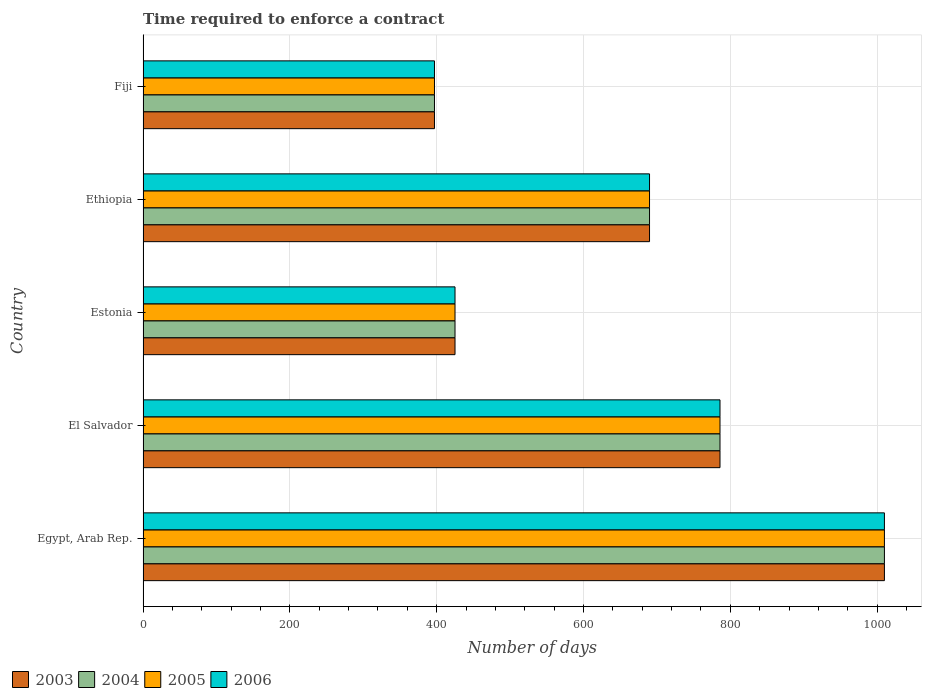How many different coloured bars are there?
Keep it short and to the point. 4. Are the number of bars per tick equal to the number of legend labels?
Provide a short and direct response. Yes. What is the label of the 1st group of bars from the top?
Give a very brief answer. Fiji. What is the number of days required to enforce a contract in 2003 in El Salvador?
Your answer should be very brief. 786. Across all countries, what is the maximum number of days required to enforce a contract in 2006?
Offer a terse response. 1010. Across all countries, what is the minimum number of days required to enforce a contract in 2003?
Offer a very short reply. 397. In which country was the number of days required to enforce a contract in 2006 maximum?
Provide a short and direct response. Egypt, Arab Rep. In which country was the number of days required to enforce a contract in 2005 minimum?
Provide a short and direct response. Fiji. What is the total number of days required to enforce a contract in 2006 in the graph?
Make the answer very short. 3308. What is the difference between the number of days required to enforce a contract in 2004 in Estonia and the number of days required to enforce a contract in 2006 in Ethiopia?
Keep it short and to the point. -265. What is the average number of days required to enforce a contract in 2005 per country?
Offer a very short reply. 661.6. In how many countries, is the number of days required to enforce a contract in 2004 greater than 840 days?
Provide a short and direct response. 1. What is the ratio of the number of days required to enforce a contract in 2003 in Egypt, Arab Rep. to that in El Salvador?
Ensure brevity in your answer.  1.28. Is the difference between the number of days required to enforce a contract in 2006 in Egypt, Arab Rep. and El Salvador greater than the difference between the number of days required to enforce a contract in 2004 in Egypt, Arab Rep. and El Salvador?
Provide a short and direct response. No. What is the difference between the highest and the second highest number of days required to enforce a contract in 2004?
Give a very brief answer. 224. What is the difference between the highest and the lowest number of days required to enforce a contract in 2005?
Your response must be concise. 613. In how many countries, is the number of days required to enforce a contract in 2006 greater than the average number of days required to enforce a contract in 2006 taken over all countries?
Offer a very short reply. 3. What does the 2nd bar from the bottom in Ethiopia represents?
Keep it short and to the point. 2004. Does the graph contain grids?
Your answer should be compact. Yes. Where does the legend appear in the graph?
Make the answer very short. Bottom left. How are the legend labels stacked?
Provide a succinct answer. Horizontal. What is the title of the graph?
Offer a very short reply. Time required to enforce a contract. What is the label or title of the X-axis?
Provide a succinct answer. Number of days. What is the Number of days of 2003 in Egypt, Arab Rep.?
Your answer should be compact. 1010. What is the Number of days of 2004 in Egypt, Arab Rep.?
Ensure brevity in your answer.  1010. What is the Number of days in 2005 in Egypt, Arab Rep.?
Offer a very short reply. 1010. What is the Number of days in 2006 in Egypt, Arab Rep.?
Your response must be concise. 1010. What is the Number of days in 2003 in El Salvador?
Offer a very short reply. 786. What is the Number of days in 2004 in El Salvador?
Offer a very short reply. 786. What is the Number of days of 2005 in El Salvador?
Offer a terse response. 786. What is the Number of days in 2006 in El Salvador?
Provide a short and direct response. 786. What is the Number of days in 2003 in Estonia?
Give a very brief answer. 425. What is the Number of days of 2004 in Estonia?
Provide a succinct answer. 425. What is the Number of days in 2005 in Estonia?
Make the answer very short. 425. What is the Number of days of 2006 in Estonia?
Ensure brevity in your answer.  425. What is the Number of days in 2003 in Ethiopia?
Give a very brief answer. 690. What is the Number of days of 2004 in Ethiopia?
Your response must be concise. 690. What is the Number of days of 2005 in Ethiopia?
Keep it short and to the point. 690. What is the Number of days of 2006 in Ethiopia?
Give a very brief answer. 690. What is the Number of days in 2003 in Fiji?
Ensure brevity in your answer.  397. What is the Number of days in 2004 in Fiji?
Your answer should be very brief. 397. What is the Number of days of 2005 in Fiji?
Keep it short and to the point. 397. What is the Number of days of 2006 in Fiji?
Offer a very short reply. 397. Across all countries, what is the maximum Number of days in 2003?
Your response must be concise. 1010. Across all countries, what is the maximum Number of days in 2004?
Give a very brief answer. 1010. Across all countries, what is the maximum Number of days in 2005?
Provide a succinct answer. 1010. Across all countries, what is the maximum Number of days in 2006?
Make the answer very short. 1010. Across all countries, what is the minimum Number of days of 2003?
Offer a terse response. 397. Across all countries, what is the minimum Number of days of 2004?
Provide a succinct answer. 397. Across all countries, what is the minimum Number of days in 2005?
Make the answer very short. 397. Across all countries, what is the minimum Number of days in 2006?
Provide a succinct answer. 397. What is the total Number of days of 2003 in the graph?
Your answer should be very brief. 3308. What is the total Number of days of 2004 in the graph?
Your answer should be compact. 3308. What is the total Number of days in 2005 in the graph?
Provide a succinct answer. 3308. What is the total Number of days in 2006 in the graph?
Provide a succinct answer. 3308. What is the difference between the Number of days in 2003 in Egypt, Arab Rep. and that in El Salvador?
Provide a short and direct response. 224. What is the difference between the Number of days in 2004 in Egypt, Arab Rep. and that in El Salvador?
Your answer should be very brief. 224. What is the difference between the Number of days of 2005 in Egypt, Arab Rep. and that in El Salvador?
Your response must be concise. 224. What is the difference between the Number of days in 2006 in Egypt, Arab Rep. and that in El Salvador?
Give a very brief answer. 224. What is the difference between the Number of days of 2003 in Egypt, Arab Rep. and that in Estonia?
Give a very brief answer. 585. What is the difference between the Number of days in 2004 in Egypt, Arab Rep. and that in Estonia?
Provide a short and direct response. 585. What is the difference between the Number of days in 2005 in Egypt, Arab Rep. and that in Estonia?
Your response must be concise. 585. What is the difference between the Number of days in 2006 in Egypt, Arab Rep. and that in Estonia?
Keep it short and to the point. 585. What is the difference between the Number of days in 2003 in Egypt, Arab Rep. and that in Ethiopia?
Your response must be concise. 320. What is the difference between the Number of days in 2004 in Egypt, Arab Rep. and that in Ethiopia?
Ensure brevity in your answer.  320. What is the difference between the Number of days in 2005 in Egypt, Arab Rep. and that in Ethiopia?
Provide a short and direct response. 320. What is the difference between the Number of days in 2006 in Egypt, Arab Rep. and that in Ethiopia?
Provide a short and direct response. 320. What is the difference between the Number of days in 2003 in Egypt, Arab Rep. and that in Fiji?
Offer a very short reply. 613. What is the difference between the Number of days of 2004 in Egypt, Arab Rep. and that in Fiji?
Your response must be concise. 613. What is the difference between the Number of days of 2005 in Egypt, Arab Rep. and that in Fiji?
Provide a succinct answer. 613. What is the difference between the Number of days of 2006 in Egypt, Arab Rep. and that in Fiji?
Provide a short and direct response. 613. What is the difference between the Number of days in 2003 in El Salvador and that in Estonia?
Your answer should be very brief. 361. What is the difference between the Number of days in 2004 in El Salvador and that in Estonia?
Provide a short and direct response. 361. What is the difference between the Number of days of 2005 in El Salvador and that in Estonia?
Provide a short and direct response. 361. What is the difference between the Number of days in 2006 in El Salvador and that in Estonia?
Give a very brief answer. 361. What is the difference between the Number of days of 2003 in El Salvador and that in Ethiopia?
Make the answer very short. 96. What is the difference between the Number of days of 2004 in El Salvador and that in Ethiopia?
Provide a short and direct response. 96. What is the difference between the Number of days of 2005 in El Salvador and that in Ethiopia?
Offer a very short reply. 96. What is the difference between the Number of days in 2006 in El Salvador and that in Ethiopia?
Your response must be concise. 96. What is the difference between the Number of days of 2003 in El Salvador and that in Fiji?
Your answer should be compact. 389. What is the difference between the Number of days of 2004 in El Salvador and that in Fiji?
Ensure brevity in your answer.  389. What is the difference between the Number of days of 2005 in El Salvador and that in Fiji?
Your answer should be compact. 389. What is the difference between the Number of days in 2006 in El Salvador and that in Fiji?
Your answer should be very brief. 389. What is the difference between the Number of days of 2003 in Estonia and that in Ethiopia?
Provide a short and direct response. -265. What is the difference between the Number of days in 2004 in Estonia and that in Ethiopia?
Offer a very short reply. -265. What is the difference between the Number of days of 2005 in Estonia and that in Ethiopia?
Your answer should be very brief. -265. What is the difference between the Number of days of 2006 in Estonia and that in Ethiopia?
Provide a short and direct response. -265. What is the difference between the Number of days of 2003 in Estonia and that in Fiji?
Provide a succinct answer. 28. What is the difference between the Number of days of 2003 in Ethiopia and that in Fiji?
Keep it short and to the point. 293. What is the difference between the Number of days in 2004 in Ethiopia and that in Fiji?
Your response must be concise. 293. What is the difference between the Number of days in 2005 in Ethiopia and that in Fiji?
Ensure brevity in your answer.  293. What is the difference between the Number of days in 2006 in Ethiopia and that in Fiji?
Your answer should be compact. 293. What is the difference between the Number of days of 2003 in Egypt, Arab Rep. and the Number of days of 2004 in El Salvador?
Your answer should be compact. 224. What is the difference between the Number of days in 2003 in Egypt, Arab Rep. and the Number of days in 2005 in El Salvador?
Give a very brief answer. 224. What is the difference between the Number of days in 2003 in Egypt, Arab Rep. and the Number of days in 2006 in El Salvador?
Offer a very short reply. 224. What is the difference between the Number of days in 2004 in Egypt, Arab Rep. and the Number of days in 2005 in El Salvador?
Your answer should be compact. 224. What is the difference between the Number of days of 2004 in Egypt, Arab Rep. and the Number of days of 2006 in El Salvador?
Your answer should be compact. 224. What is the difference between the Number of days of 2005 in Egypt, Arab Rep. and the Number of days of 2006 in El Salvador?
Your answer should be very brief. 224. What is the difference between the Number of days in 2003 in Egypt, Arab Rep. and the Number of days in 2004 in Estonia?
Keep it short and to the point. 585. What is the difference between the Number of days of 2003 in Egypt, Arab Rep. and the Number of days of 2005 in Estonia?
Provide a short and direct response. 585. What is the difference between the Number of days in 2003 in Egypt, Arab Rep. and the Number of days in 2006 in Estonia?
Ensure brevity in your answer.  585. What is the difference between the Number of days in 2004 in Egypt, Arab Rep. and the Number of days in 2005 in Estonia?
Make the answer very short. 585. What is the difference between the Number of days in 2004 in Egypt, Arab Rep. and the Number of days in 2006 in Estonia?
Give a very brief answer. 585. What is the difference between the Number of days of 2005 in Egypt, Arab Rep. and the Number of days of 2006 in Estonia?
Your answer should be very brief. 585. What is the difference between the Number of days in 2003 in Egypt, Arab Rep. and the Number of days in 2004 in Ethiopia?
Provide a short and direct response. 320. What is the difference between the Number of days in 2003 in Egypt, Arab Rep. and the Number of days in 2005 in Ethiopia?
Provide a short and direct response. 320. What is the difference between the Number of days in 2003 in Egypt, Arab Rep. and the Number of days in 2006 in Ethiopia?
Offer a terse response. 320. What is the difference between the Number of days of 2004 in Egypt, Arab Rep. and the Number of days of 2005 in Ethiopia?
Your response must be concise. 320. What is the difference between the Number of days in 2004 in Egypt, Arab Rep. and the Number of days in 2006 in Ethiopia?
Provide a short and direct response. 320. What is the difference between the Number of days in 2005 in Egypt, Arab Rep. and the Number of days in 2006 in Ethiopia?
Make the answer very short. 320. What is the difference between the Number of days in 2003 in Egypt, Arab Rep. and the Number of days in 2004 in Fiji?
Your response must be concise. 613. What is the difference between the Number of days in 2003 in Egypt, Arab Rep. and the Number of days in 2005 in Fiji?
Offer a terse response. 613. What is the difference between the Number of days of 2003 in Egypt, Arab Rep. and the Number of days of 2006 in Fiji?
Provide a short and direct response. 613. What is the difference between the Number of days of 2004 in Egypt, Arab Rep. and the Number of days of 2005 in Fiji?
Offer a very short reply. 613. What is the difference between the Number of days of 2004 in Egypt, Arab Rep. and the Number of days of 2006 in Fiji?
Keep it short and to the point. 613. What is the difference between the Number of days in 2005 in Egypt, Arab Rep. and the Number of days in 2006 in Fiji?
Ensure brevity in your answer.  613. What is the difference between the Number of days of 2003 in El Salvador and the Number of days of 2004 in Estonia?
Ensure brevity in your answer.  361. What is the difference between the Number of days in 2003 in El Salvador and the Number of days in 2005 in Estonia?
Keep it short and to the point. 361. What is the difference between the Number of days in 2003 in El Salvador and the Number of days in 2006 in Estonia?
Ensure brevity in your answer.  361. What is the difference between the Number of days of 2004 in El Salvador and the Number of days of 2005 in Estonia?
Your answer should be compact. 361. What is the difference between the Number of days in 2004 in El Salvador and the Number of days in 2006 in Estonia?
Offer a very short reply. 361. What is the difference between the Number of days in 2005 in El Salvador and the Number of days in 2006 in Estonia?
Keep it short and to the point. 361. What is the difference between the Number of days of 2003 in El Salvador and the Number of days of 2004 in Ethiopia?
Make the answer very short. 96. What is the difference between the Number of days of 2003 in El Salvador and the Number of days of 2005 in Ethiopia?
Give a very brief answer. 96. What is the difference between the Number of days of 2003 in El Salvador and the Number of days of 2006 in Ethiopia?
Offer a terse response. 96. What is the difference between the Number of days in 2004 in El Salvador and the Number of days in 2005 in Ethiopia?
Make the answer very short. 96. What is the difference between the Number of days in 2004 in El Salvador and the Number of days in 2006 in Ethiopia?
Offer a terse response. 96. What is the difference between the Number of days of 2005 in El Salvador and the Number of days of 2006 in Ethiopia?
Your response must be concise. 96. What is the difference between the Number of days of 2003 in El Salvador and the Number of days of 2004 in Fiji?
Keep it short and to the point. 389. What is the difference between the Number of days in 2003 in El Salvador and the Number of days in 2005 in Fiji?
Make the answer very short. 389. What is the difference between the Number of days of 2003 in El Salvador and the Number of days of 2006 in Fiji?
Ensure brevity in your answer.  389. What is the difference between the Number of days of 2004 in El Salvador and the Number of days of 2005 in Fiji?
Offer a terse response. 389. What is the difference between the Number of days in 2004 in El Salvador and the Number of days in 2006 in Fiji?
Offer a very short reply. 389. What is the difference between the Number of days in 2005 in El Salvador and the Number of days in 2006 in Fiji?
Provide a succinct answer. 389. What is the difference between the Number of days in 2003 in Estonia and the Number of days in 2004 in Ethiopia?
Ensure brevity in your answer.  -265. What is the difference between the Number of days of 2003 in Estonia and the Number of days of 2005 in Ethiopia?
Provide a succinct answer. -265. What is the difference between the Number of days of 2003 in Estonia and the Number of days of 2006 in Ethiopia?
Keep it short and to the point. -265. What is the difference between the Number of days of 2004 in Estonia and the Number of days of 2005 in Ethiopia?
Ensure brevity in your answer.  -265. What is the difference between the Number of days of 2004 in Estonia and the Number of days of 2006 in Ethiopia?
Offer a very short reply. -265. What is the difference between the Number of days in 2005 in Estonia and the Number of days in 2006 in Ethiopia?
Your answer should be very brief. -265. What is the difference between the Number of days of 2004 in Estonia and the Number of days of 2005 in Fiji?
Offer a terse response. 28. What is the difference between the Number of days in 2003 in Ethiopia and the Number of days in 2004 in Fiji?
Make the answer very short. 293. What is the difference between the Number of days in 2003 in Ethiopia and the Number of days in 2005 in Fiji?
Your answer should be very brief. 293. What is the difference between the Number of days in 2003 in Ethiopia and the Number of days in 2006 in Fiji?
Your response must be concise. 293. What is the difference between the Number of days in 2004 in Ethiopia and the Number of days in 2005 in Fiji?
Provide a short and direct response. 293. What is the difference between the Number of days of 2004 in Ethiopia and the Number of days of 2006 in Fiji?
Provide a succinct answer. 293. What is the difference between the Number of days of 2005 in Ethiopia and the Number of days of 2006 in Fiji?
Your answer should be compact. 293. What is the average Number of days of 2003 per country?
Ensure brevity in your answer.  661.6. What is the average Number of days in 2004 per country?
Offer a very short reply. 661.6. What is the average Number of days in 2005 per country?
Your answer should be very brief. 661.6. What is the average Number of days of 2006 per country?
Provide a short and direct response. 661.6. What is the difference between the Number of days of 2003 and Number of days of 2005 in Egypt, Arab Rep.?
Your response must be concise. 0. What is the difference between the Number of days in 2003 and Number of days in 2004 in El Salvador?
Your response must be concise. 0. What is the difference between the Number of days of 2003 and Number of days of 2005 in El Salvador?
Provide a succinct answer. 0. What is the difference between the Number of days in 2003 and Number of days in 2004 in Estonia?
Your answer should be compact. 0. What is the difference between the Number of days in 2003 and Number of days in 2006 in Estonia?
Make the answer very short. 0. What is the difference between the Number of days in 2004 and Number of days in 2006 in Estonia?
Your answer should be compact. 0. What is the difference between the Number of days of 2003 and Number of days of 2004 in Ethiopia?
Your answer should be very brief. 0. What is the difference between the Number of days of 2003 and Number of days of 2005 in Ethiopia?
Give a very brief answer. 0. What is the difference between the Number of days of 2003 and Number of days of 2006 in Ethiopia?
Your answer should be very brief. 0. What is the difference between the Number of days of 2005 and Number of days of 2006 in Ethiopia?
Your answer should be very brief. 0. What is the difference between the Number of days in 2003 and Number of days in 2006 in Fiji?
Offer a very short reply. 0. What is the difference between the Number of days in 2004 and Number of days in 2005 in Fiji?
Give a very brief answer. 0. What is the difference between the Number of days in 2004 and Number of days in 2006 in Fiji?
Your answer should be compact. 0. What is the difference between the Number of days of 2005 and Number of days of 2006 in Fiji?
Keep it short and to the point. 0. What is the ratio of the Number of days in 2003 in Egypt, Arab Rep. to that in El Salvador?
Your response must be concise. 1.28. What is the ratio of the Number of days of 2004 in Egypt, Arab Rep. to that in El Salvador?
Keep it short and to the point. 1.28. What is the ratio of the Number of days of 2005 in Egypt, Arab Rep. to that in El Salvador?
Provide a succinct answer. 1.28. What is the ratio of the Number of days of 2006 in Egypt, Arab Rep. to that in El Salvador?
Your answer should be compact. 1.28. What is the ratio of the Number of days in 2003 in Egypt, Arab Rep. to that in Estonia?
Your answer should be very brief. 2.38. What is the ratio of the Number of days in 2004 in Egypt, Arab Rep. to that in Estonia?
Your answer should be compact. 2.38. What is the ratio of the Number of days in 2005 in Egypt, Arab Rep. to that in Estonia?
Provide a succinct answer. 2.38. What is the ratio of the Number of days of 2006 in Egypt, Arab Rep. to that in Estonia?
Your response must be concise. 2.38. What is the ratio of the Number of days of 2003 in Egypt, Arab Rep. to that in Ethiopia?
Give a very brief answer. 1.46. What is the ratio of the Number of days of 2004 in Egypt, Arab Rep. to that in Ethiopia?
Your answer should be very brief. 1.46. What is the ratio of the Number of days in 2005 in Egypt, Arab Rep. to that in Ethiopia?
Your response must be concise. 1.46. What is the ratio of the Number of days of 2006 in Egypt, Arab Rep. to that in Ethiopia?
Your response must be concise. 1.46. What is the ratio of the Number of days in 2003 in Egypt, Arab Rep. to that in Fiji?
Provide a short and direct response. 2.54. What is the ratio of the Number of days in 2004 in Egypt, Arab Rep. to that in Fiji?
Keep it short and to the point. 2.54. What is the ratio of the Number of days in 2005 in Egypt, Arab Rep. to that in Fiji?
Give a very brief answer. 2.54. What is the ratio of the Number of days of 2006 in Egypt, Arab Rep. to that in Fiji?
Provide a succinct answer. 2.54. What is the ratio of the Number of days of 2003 in El Salvador to that in Estonia?
Give a very brief answer. 1.85. What is the ratio of the Number of days of 2004 in El Salvador to that in Estonia?
Provide a short and direct response. 1.85. What is the ratio of the Number of days of 2005 in El Salvador to that in Estonia?
Give a very brief answer. 1.85. What is the ratio of the Number of days of 2006 in El Salvador to that in Estonia?
Offer a very short reply. 1.85. What is the ratio of the Number of days in 2003 in El Salvador to that in Ethiopia?
Ensure brevity in your answer.  1.14. What is the ratio of the Number of days in 2004 in El Salvador to that in Ethiopia?
Offer a terse response. 1.14. What is the ratio of the Number of days in 2005 in El Salvador to that in Ethiopia?
Give a very brief answer. 1.14. What is the ratio of the Number of days in 2006 in El Salvador to that in Ethiopia?
Your response must be concise. 1.14. What is the ratio of the Number of days of 2003 in El Salvador to that in Fiji?
Your answer should be very brief. 1.98. What is the ratio of the Number of days of 2004 in El Salvador to that in Fiji?
Offer a terse response. 1.98. What is the ratio of the Number of days in 2005 in El Salvador to that in Fiji?
Provide a short and direct response. 1.98. What is the ratio of the Number of days of 2006 in El Salvador to that in Fiji?
Offer a terse response. 1.98. What is the ratio of the Number of days of 2003 in Estonia to that in Ethiopia?
Ensure brevity in your answer.  0.62. What is the ratio of the Number of days in 2004 in Estonia to that in Ethiopia?
Ensure brevity in your answer.  0.62. What is the ratio of the Number of days of 2005 in Estonia to that in Ethiopia?
Make the answer very short. 0.62. What is the ratio of the Number of days of 2006 in Estonia to that in Ethiopia?
Your response must be concise. 0.62. What is the ratio of the Number of days of 2003 in Estonia to that in Fiji?
Offer a terse response. 1.07. What is the ratio of the Number of days in 2004 in Estonia to that in Fiji?
Keep it short and to the point. 1.07. What is the ratio of the Number of days in 2005 in Estonia to that in Fiji?
Offer a very short reply. 1.07. What is the ratio of the Number of days in 2006 in Estonia to that in Fiji?
Your answer should be very brief. 1.07. What is the ratio of the Number of days in 2003 in Ethiopia to that in Fiji?
Offer a very short reply. 1.74. What is the ratio of the Number of days in 2004 in Ethiopia to that in Fiji?
Make the answer very short. 1.74. What is the ratio of the Number of days of 2005 in Ethiopia to that in Fiji?
Offer a terse response. 1.74. What is the ratio of the Number of days in 2006 in Ethiopia to that in Fiji?
Your response must be concise. 1.74. What is the difference between the highest and the second highest Number of days of 2003?
Provide a succinct answer. 224. What is the difference between the highest and the second highest Number of days in 2004?
Provide a succinct answer. 224. What is the difference between the highest and the second highest Number of days in 2005?
Offer a terse response. 224. What is the difference between the highest and the second highest Number of days of 2006?
Ensure brevity in your answer.  224. What is the difference between the highest and the lowest Number of days of 2003?
Your answer should be compact. 613. What is the difference between the highest and the lowest Number of days of 2004?
Give a very brief answer. 613. What is the difference between the highest and the lowest Number of days of 2005?
Ensure brevity in your answer.  613. What is the difference between the highest and the lowest Number of days of 2006?
Provide a succinct answer. 613. 